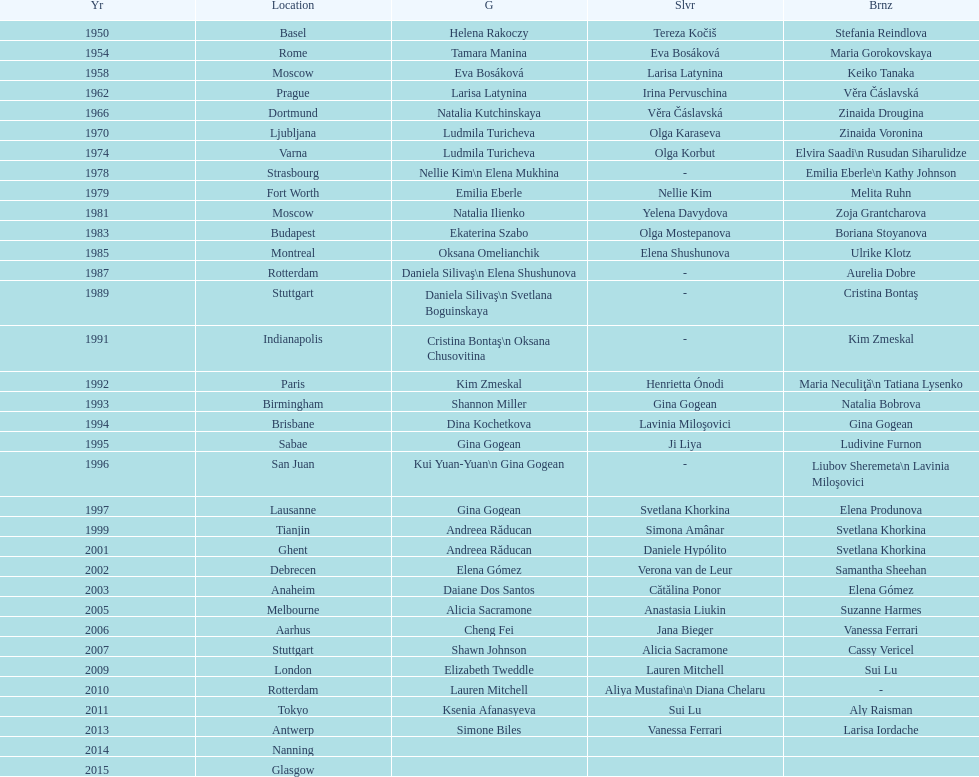What is the total number of russian gymnasts that have won silver. 8. 